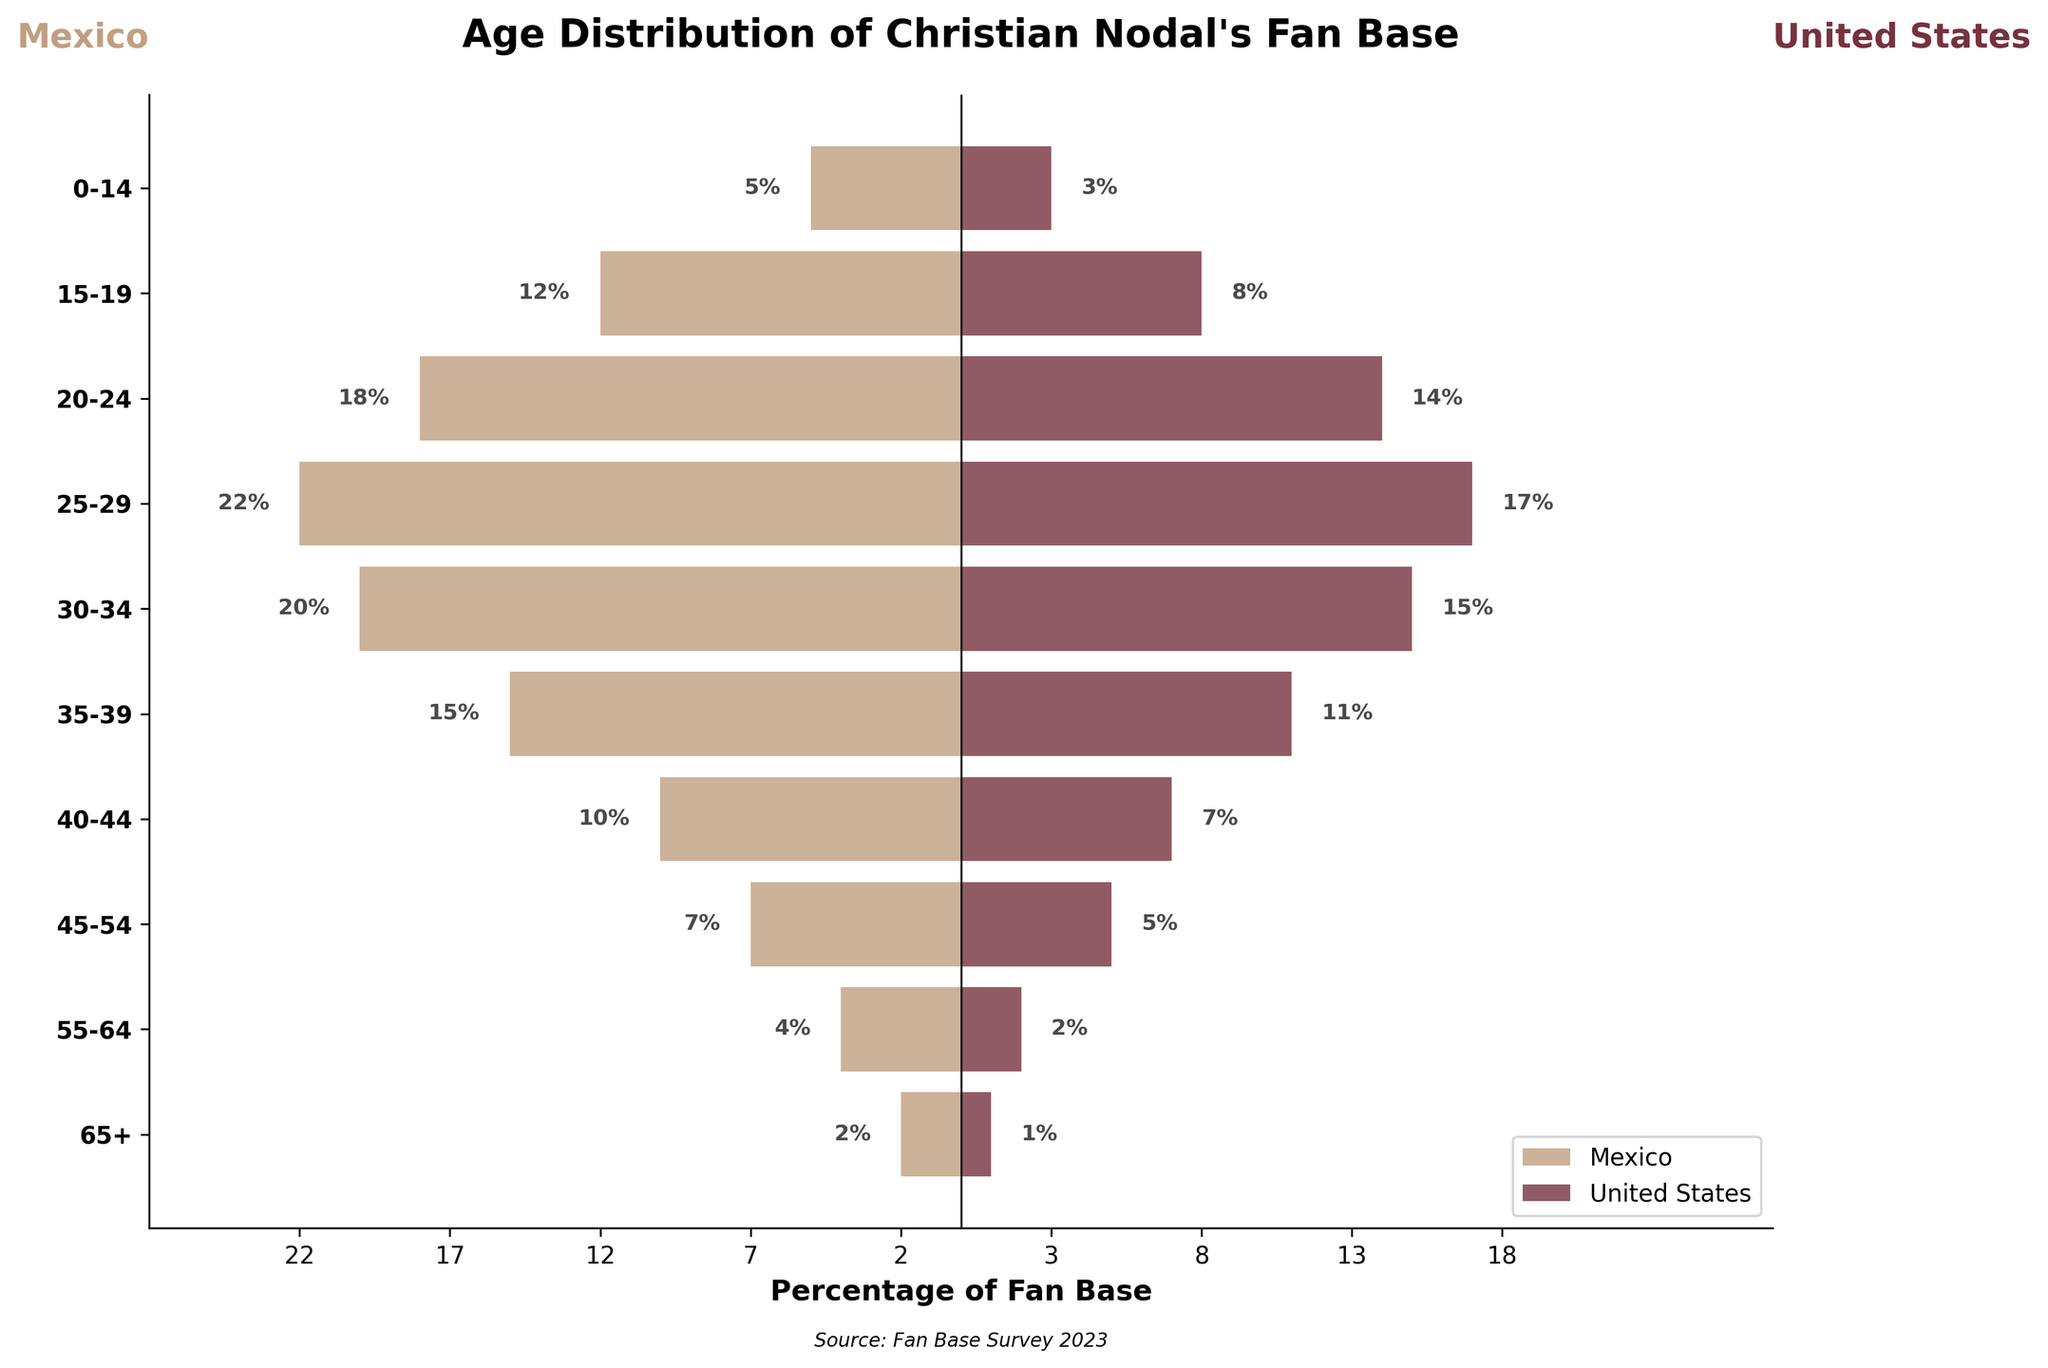what is the age group with the largest percentage of Christian Nodal's fan base in Mexico? By examining the population pyramid, the largest percentage of fan base in Mexico is observed at the age group where the bar reaches its maximum negative value. In this case, the bar for the age group 25-29 is the longest at -22%.
Answer: 25-29 What is the total percentage of Christian Nodal's fan base aged 20-34 in the United States? We add the percentages for the age groups 20-24, 25-29, and 30-34 from the United States. Therefore, 14% (20-24) + 17% (25-29) + 15% (30-34) = 46%.
Answer: 46% Which age group has a higher percentage of fans in the United States compared to Mexico? By comparing each age group's percentages for both countries, the United States has a higher percentage of fans in the 0-14, 15-19, 20-24, 25-29, 30-34, 35-39, and 40-44 age groups.
Answer: 0-14, 15-19, 20-24, 25-29, 30-34, 35-39, 40-44 How does the percentage of fans aged 55-64 in Mexico compare to those in the United States? By examining the bar lengths for the 55-64 age group, Mexico has -4% and the United States has 2%. Since -4% is less than 2%, the percentage is higher in the United States.
Answer: Higher in the United States What is the average percentage of Christian Nodal's fan base in Mexico for the age groups 40-44, 45-54, and 55-64? We sum the percentages for these three age groups in Mexico and divide by 3. Therefore, (-10 + -7 + -4) = -21, and -21/3 = -7%.
Answer: -7% In which country does the age group 40-44 have a higher percentage of fans, and by how much? By comparing the percentages in the 40-44 age group, Mexico has -10% and the United States has 7%. The difference is 7 - (-10) = 7 + 10 = 17%.
Answer: United States, by 17% What is the combined percentage of fans aged 25-34 in both countries? Combine the percentages for 25-29 and 30-34 age groups for both countries. For Mexico: (-22 + -20) = -42%. For the United States: (17 + 15) = 32%. The combined percentage is 42% + 32% = 74%.
Answer: 74% 